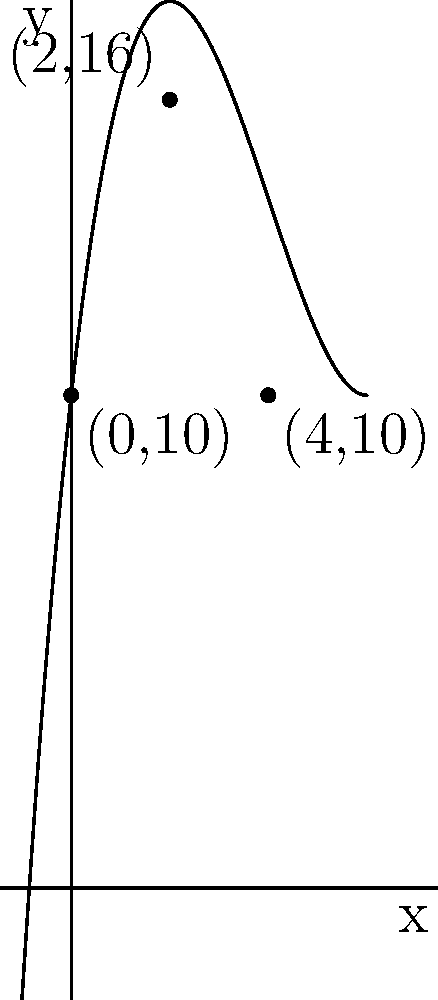In an ARCA Menards Series race, a car's trajectory can be modeled by a cubic function. The car starts at a height of 10 feet, reaches a maximum height of 16 feet at x = 2, and returns to 10 feet at x = 4. Find the cubic function f(x) that models this trajectory. Let's approach this step-by-step:

1) The general form of a cubic function is $f(x) = ax^3 + bx^2 + cx + d$.

2) We have three points: (0,10), (2,16), and (4,10). Let's use these:

   $f(0) = 10$: $d = 10$
   $f(2) = 16$: $8a + 4b + 2c + 10 = 16$
   $f(4) = 10$: $64a + 16b + 4c + 10 = 10$

3) At x = 2, we have a maximum. The derivative should be zero:
   $f'(x) = 3ax^2 + 2bx + c$
   $f'(2) = 12a + 4b + c = 0$

4) Now we have a system of equations:
   $8a + 4b + 2c = 6$
   $64a + 16b + 4c = 0$
   $12a + 4b + c = 0$

5) Solving this system (you can use substitution or matrix methods):
   $a = 0.25$
   $b = -3$
   $c = 9$

6) Therefore, the function is:
   $f(x) = 0.25x^3 - 3x^2 + 9x + 10$

This function satisfies all the given conditions and models the car's trajectory.
Answer: $f(x) = 0.25x^3 - 3x^2 + 9x + 10$ 